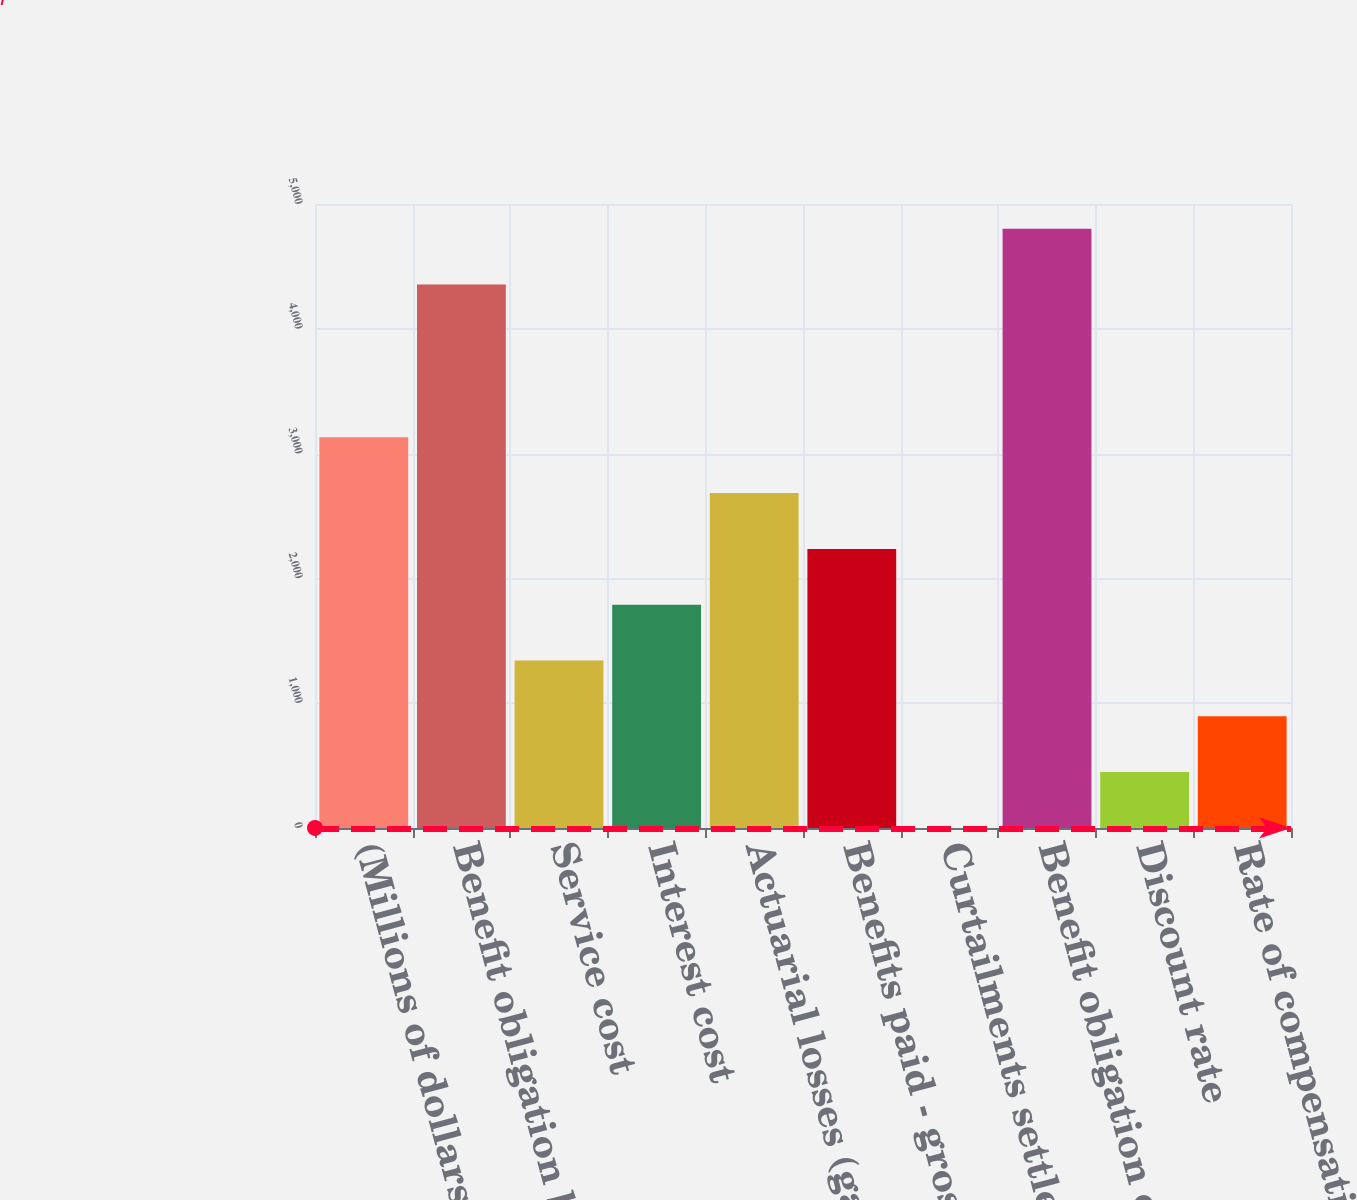<chart> <loc_0><loc_0><loc_500><loc_500><bar_chart><fcel>(Millions of dollars)<fcel>Benefit obligation beginning<fcel>Service cost<fcel>Interest cost<fcel>Actuarial losses (gains)<fcel>Benefits paid - gross<fcel>Curtailments settlements and<fcel>Benefit obligation end of year<fcel>Discount rate<fcel>Rate of compensation increase<nl><fcel>3130.7<fcel>4355<fcel>1342.3<fcel>1789.4<fcel>2683.6<fcel>2236.5<fcel>1<fcel>4802.1<fcel>448.1<fcel>895.2<nl></chart> 